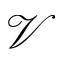<formula> <loc_0><loc_0><loc_500><loc_500>\mathcal { V }</formula> 